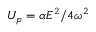Convert formula to latex. <formula><loc_0><loc_0><loc_500><loc_500>U _ { p } = \alpha E ^ { 2 } / 4 \omega ^ { 2 }</formula> 